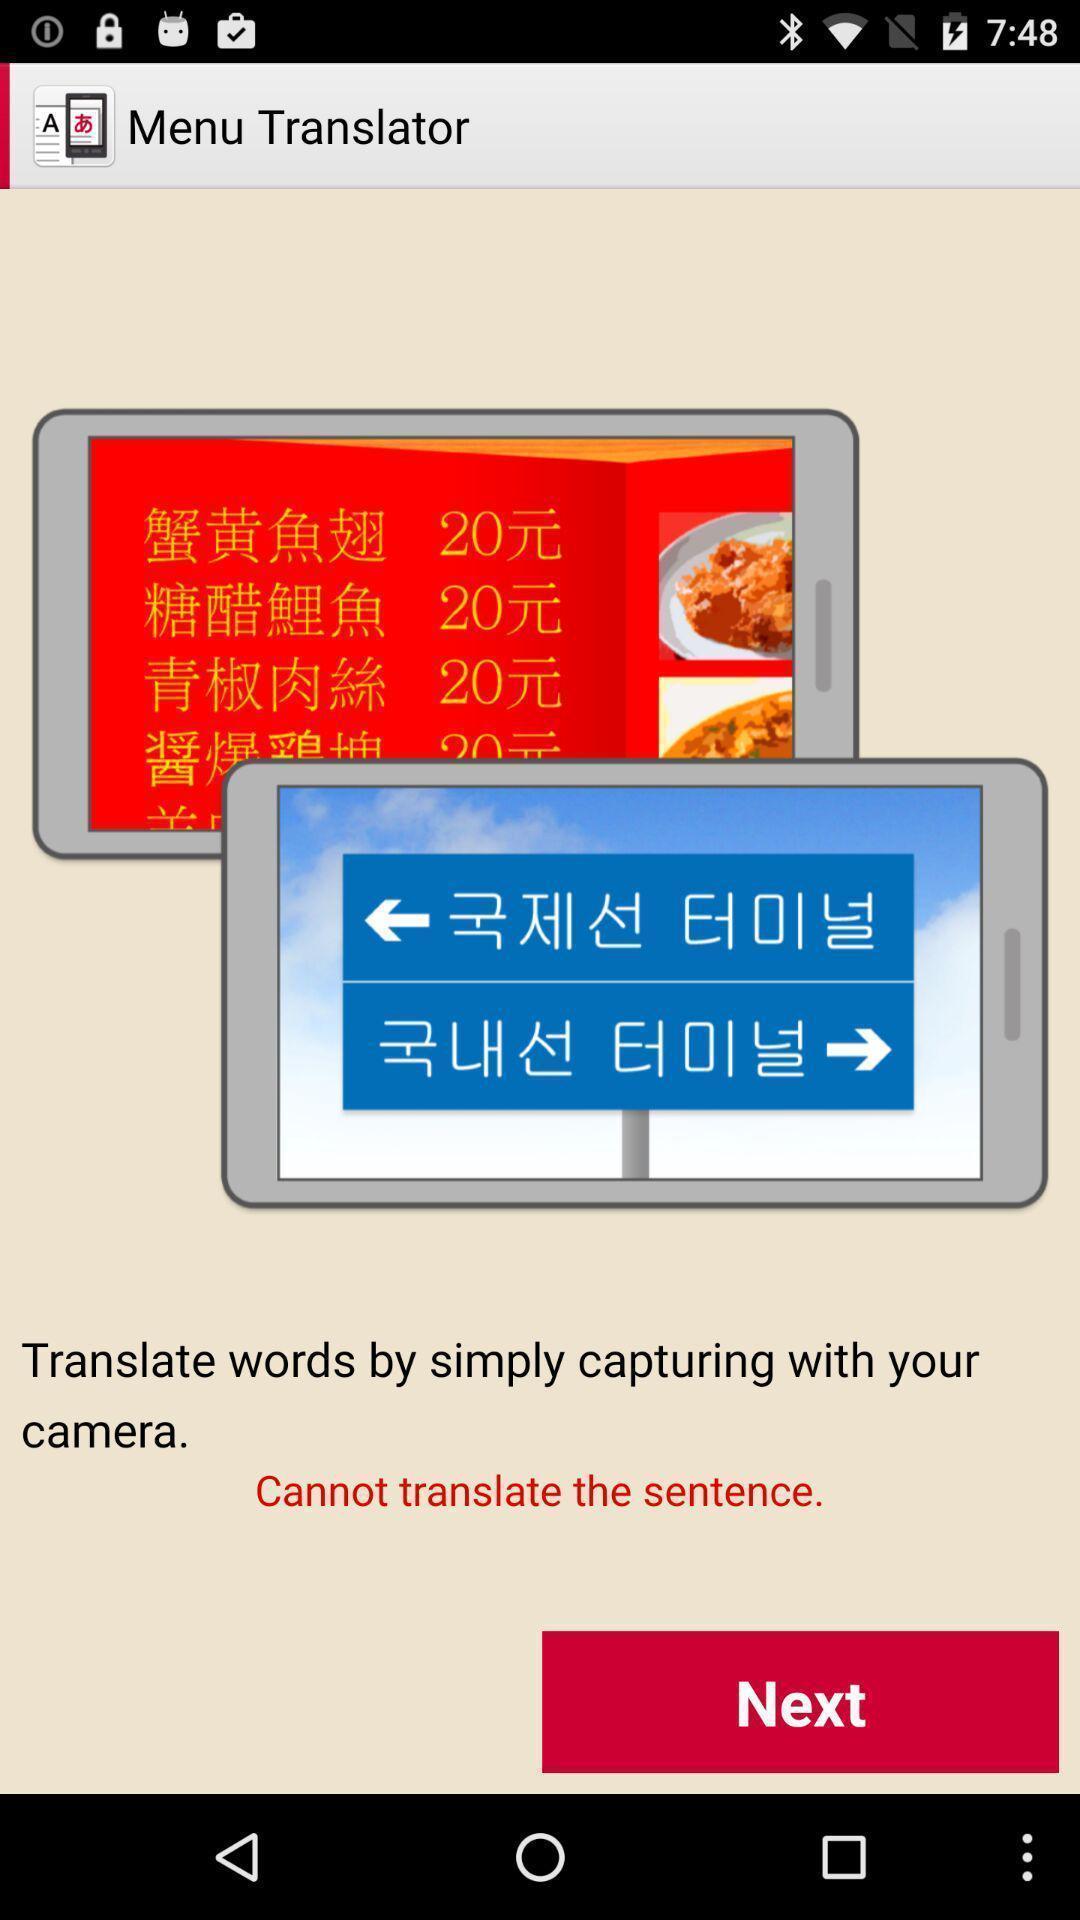Describe the content in this image. Welcome page for a translation app. 